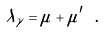Convert formula to latex. <formula><loc_0><loc_0><loc_500><loc_500>\lambda _ { \gamma } = \mu + \mu ^ { \prime } \ .</formula> 